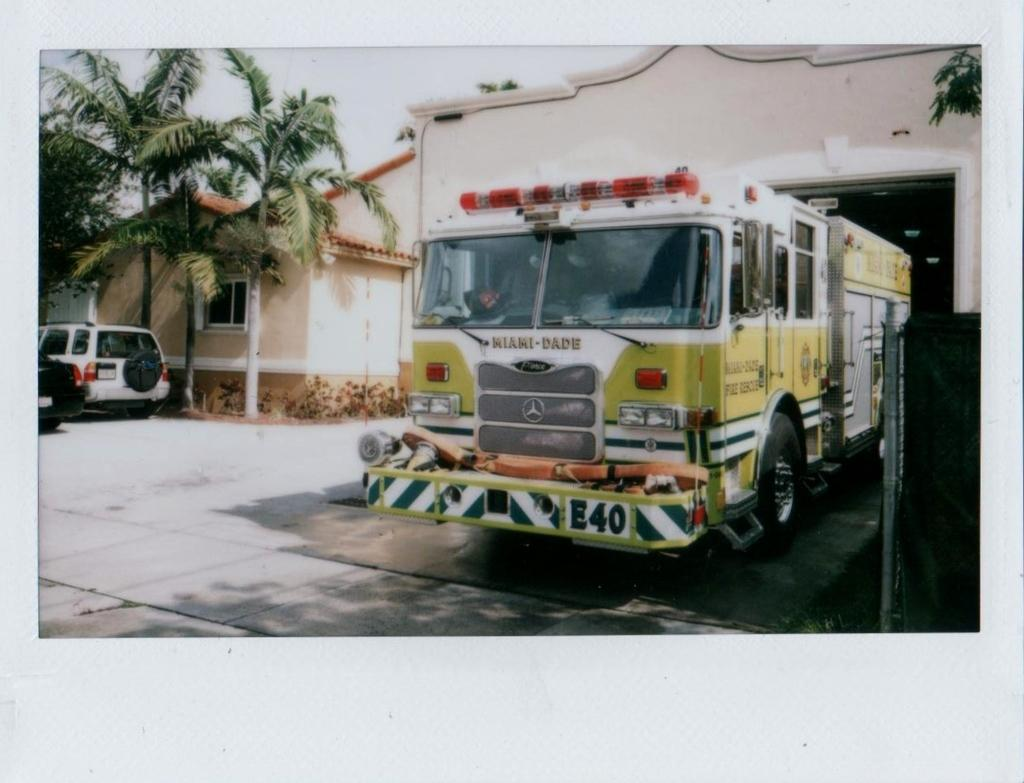What is the main subject in the foreground of the image? There is a vehicle in the foreground of the image. What else can be seen in the image besides the vehicle in the foreground? There are vehicles, trees, a house structure, and the sky visible in the background of the image. How many vehicles are visible in the image? There are at least two vehicles visible in the image, one in the foreground and others in the background. What type of natural environment is visible in the image? Trees are visible in the background of the image, indicating a natural environment. What type of downtown area can be seen in the image? There is no downtown area present in the image; it features a vehicle in the foreground and a natural environment in the background. 